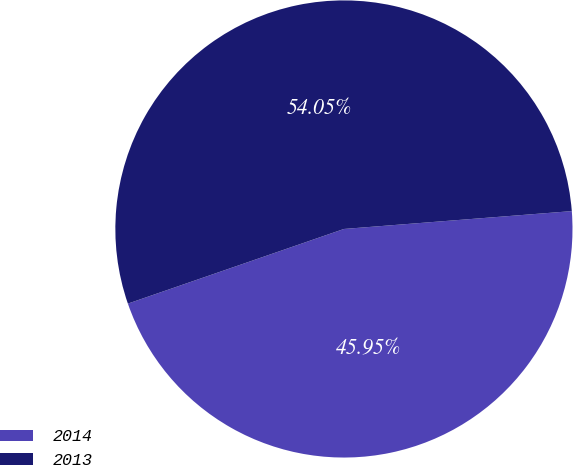Convert chart. <chart><loc_0><loc_0><loc_500><loc_500><pie_chart><fcel>2014<fcel>2013<nl><fcel>45.95%<fcel>54.05%<nl></chart> 